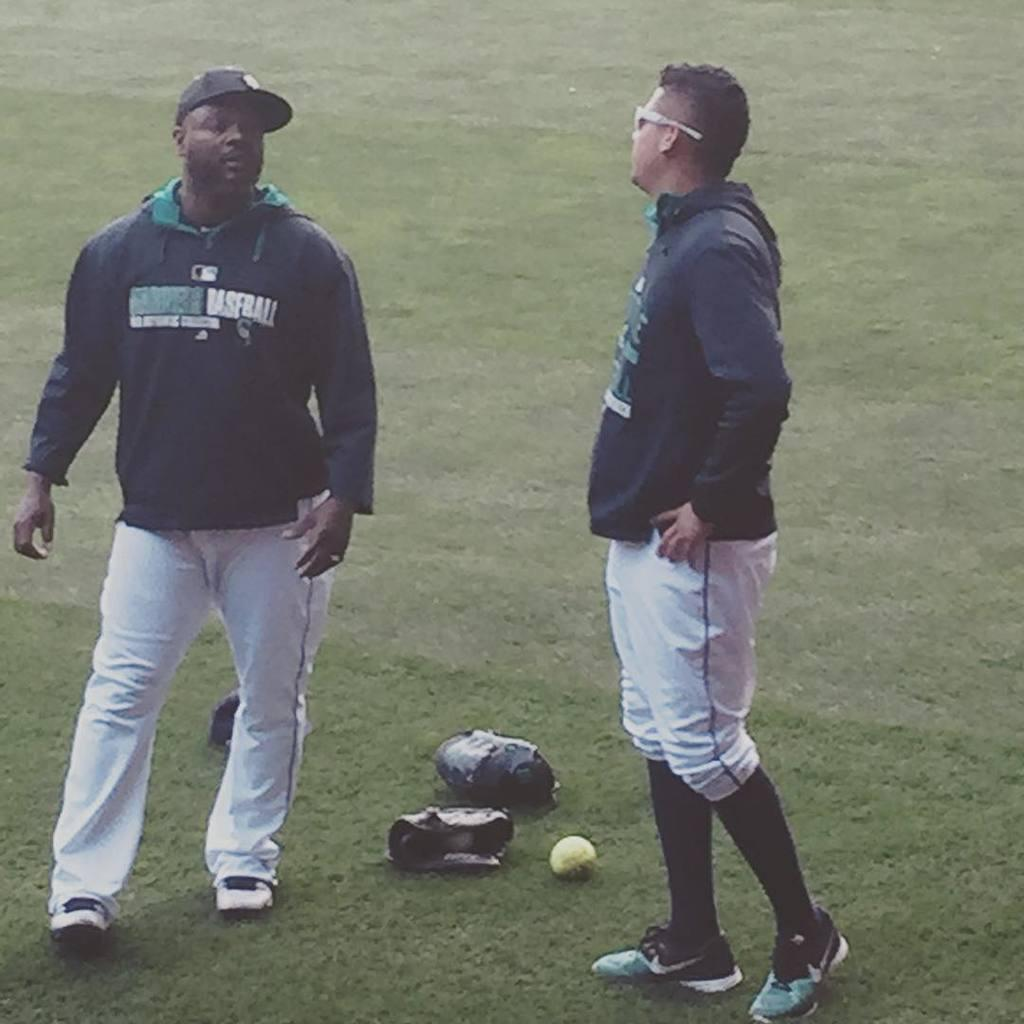<image>
Offer a succinct explanation of the picture presented. A man is wearing a jacket with the word baseball on the front. 